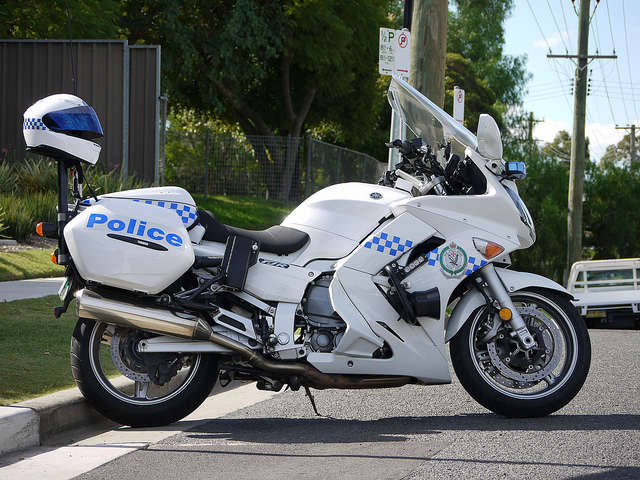<image>What kind of tree is behind the motorcycle? It is unknown what kind of tree is behind the motorcycle. It could be an oak, a maple, a pine, or an evergreen. What kind of tree is behind the motorcycle? I am not sure what kind of tree is behind the motorcycle. It can be oak, maple, pine or evergreen. 